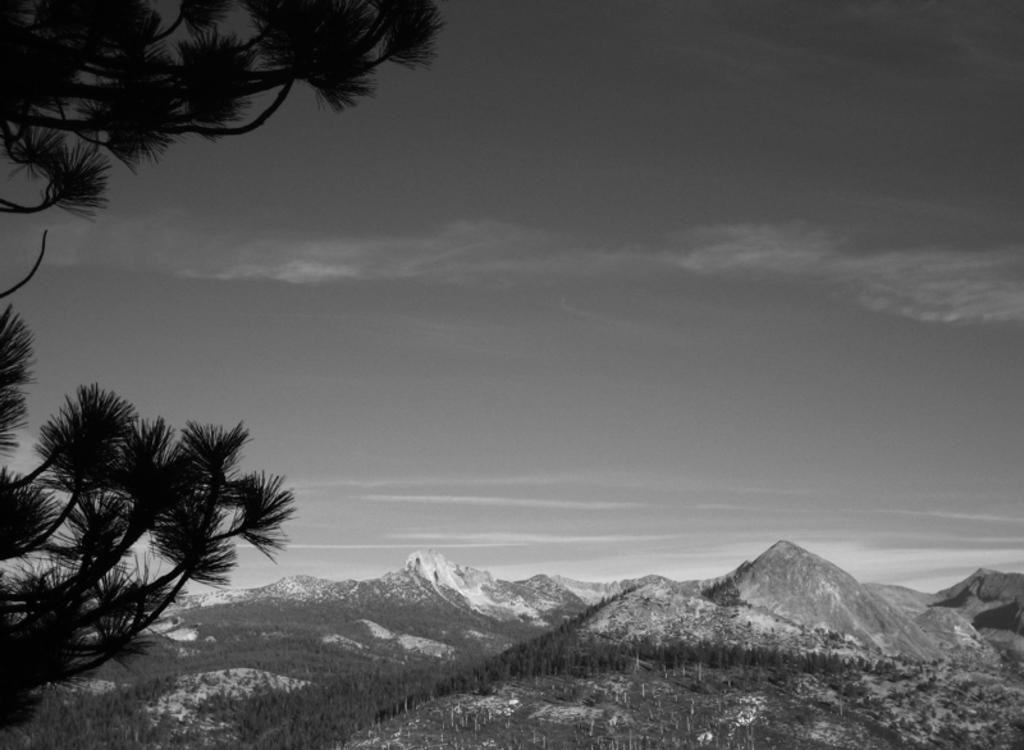Please provide a concise description of this image. In this image we can see sky with clouds, hills, trees and ground. 